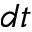Convert formula to latex. <formula><loc_0><loc_0><loc_500><loc_500>d t</formula> 